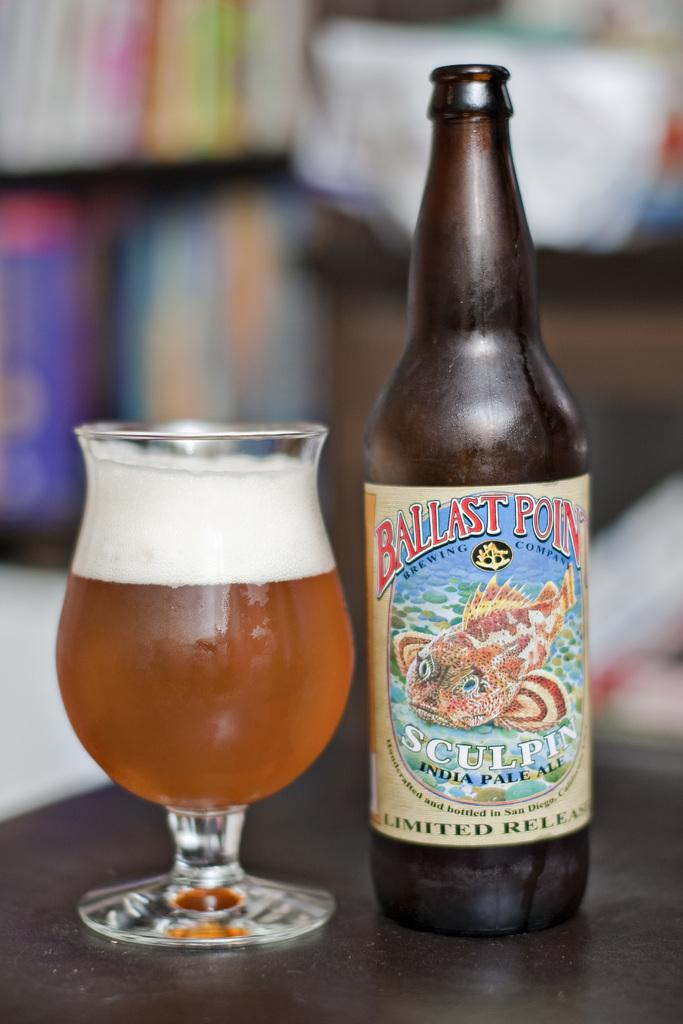<image>
Describe the image concisely. Ballast Point Brewing Company that is Sculpin India Pale Ale, bottled in San Diego California. 